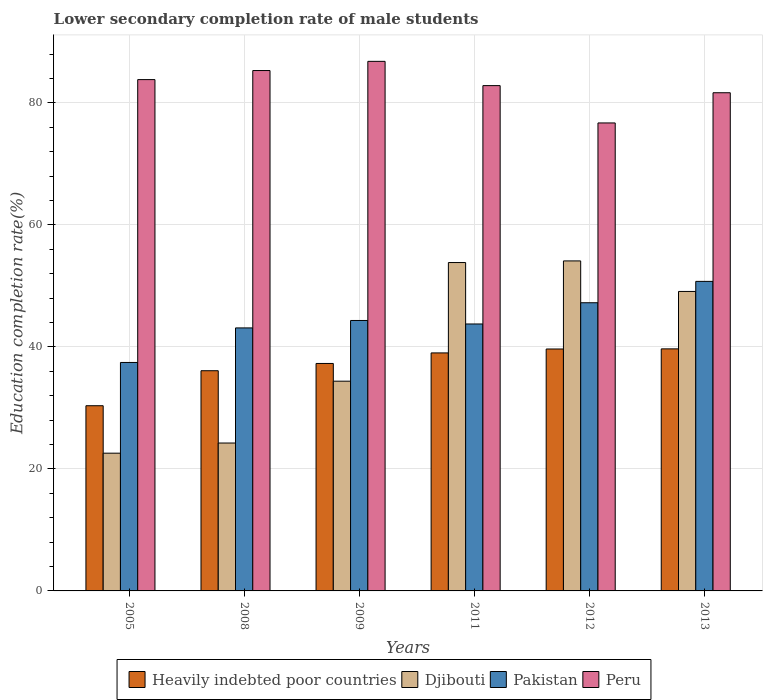How many different coloured bars are there?
Provide a succinct answer. 4. Are the number of bars per tick equal to the number of legend labels?
Give a very brief answer. Yes. How many bars are there on the 1st tick from the left?
Offer a very short reply. 4. How many bars are there on the 1st tick from the right?
Make the answer very short. 4. What is the label of the 1st group of bars from the left?
Your answer should be compact. 2005. What is the lower secondary completion rate of male students in Heavily indebted poor countries in 2008?
Make the answer very short. 36.09. Across all years, what is the maximum lower secondary completion rate of male students in Peru?
Your response must be concise. 86.8. Across all years, what is the minimum lower secondary completion rate of male students in Peru?
Your response must be concise. 76.71. In which year was the lower secondary completion rate of male students in Heavily indebted poor countries minimum?
Provide a succinct answer. 2005. What is the total lower secondary completion rate of male students in Heavily indebted poor countries in the graph?
Your response must be concise. 222.08. What is the difference between the lower secondary completion rate of male students in Peru in 2011 and that in 2012?
Offer a terse response. 6.12. What is the difference between the lower secondary completion rate of male students in Heavily indebted poor countries in 2008 and the lower secondary completion rate of male students in Pakistan in 2011?
Your answer should be compact. -7.66. What is the average lower secondary completion rate of male students in Heavily indebted poor countries per year?
Ensure brevity in your answer.  37.01. In the year 2008, what is the difference between the lower secondary completion rate of male students in Heavily indebted poor countries and lower secondary completion rate of male students in Peru?
Give a very brief answer. -49.2. What is the ratio of the lower secondary completion rate of male students in Heavily indebted poor countries in 2005 to that in 2011?
Make the answer very short. 0.78. Is the difference between the lower secondary completion rate of male students in Heavily indebted poor countries in 2005 and 2012 greater than the difference between the lower secondary completion rate of male students in Peru in 2005 and 2012?
Your answer should be compact. No. What is the difference between the highest and the second highest lower secondary completion rate of male students in Heavily indebted poor countries?
Ensure brevity in your answer.  0.02. What is the difference between the highest and the lowest lower secondary completion rate of male students in Peru?
Your response must be concise. 10.1. Is the sum of the lower secondary completion rate of male students in Heavily indebted poor countries in 2008 and 2009 greater than the maximum lower secondary completion rate of male students in Djibouti across all years?
Keep it short and to the point. Yes. What does the 2nd bar from the left in 2009 represents?
Keep it short and to the point. Djibouti. What does the 2nd bar from the right in 2013 represents?
Your answer should be very brief. Pakistan. Are all the bars in the graph horizontal?
Give a very brief answer. No. How many years are there in the graph?
Your answer should be compact. 6. What is the difference between two consecutive major ticks on the Y-axis?
Your answer should be very brief. 20. Does the graph contain grids?
Offer a very short reply. Yes. How many legend labels are there?
Provide a succinct answer. 4. What is the title of the graph?
Make the answer very short. Lower secondary completion rate of male students. What is the label or title of the X-axis?
Keep it short and to the point. Years. What is the label or title of the Y-axis?
Offer a terse response. Education completion rate(%). What is the Education completion rate(%) in Heavily indebted poor countries in 2005?
Give a very brief answer. 30.36. What is the Education completion rate(%) of Djibouti in 2005?
Ensure brevity in your answer.  22.58. What is the Education completion rate(%) in Pakistan in 2005?
Give a very brief answer. 37.45. What is the Education completion rate(%) in Peru in 2005?
Offer a terse response. 83.81. What is the Education completion rate(%) of Heavily indebted poor countries in 2008?
Keep it short and to the point. 36.09. What is the Education completion rate(%) of Djibouti in 2008?
Keep it short and to the point. 24.24. What is the Education completion rate(%) in Pakistan in 2008?
Give a very brief answer. 43.11. What is the Education completion rate(%) of Peru in 2008?
Make the answer very short. 85.3. What is the Education completion rate(%) in Heavily indebted poor countries in 2009?
Ensure brevity in your answer.  37.29. What is the Education completion rate(%) of Djibouti in 2009?
Offer a very short reply. 34.38. What is the Education completion rate(%) of Pakistan in 2009?
Keep it short and to the point. 44.33. What is the Education completion rate(%) of Peru in 2009?
Offer a very short reply. 86.8. What is the Education completion rate(%) of Heavily indebted poor countries in 2011?
Provide a succinct answer. 39.01. What is the Education completion rate(%) of Djibouti in 2011?
Offer a very short reply. 53.83. What is the Education completion rate(%) of Pakistan in 2011?
Offer a terse response. 43.76. What is the Education completion rate(%) of Peru in 2011?
Your answer should be compact. 82.83. What is the Education completion rate(%) in Heavily indebted poor countries in 2012?
Your answer should be compact. 39.65. What is the Education completion rate(%) of Djibouti in 2012?
Offer a very short reply. 54.09. What is the Education completion rate(%) of Pakistan in 2012?
Ensure brevity in your answer.  47.24. What is the Education completion rate(%) of Peru in 2012?
Give a very brief answer. 76.71. What is the Education completion rate(%) of Heavily indebted poor countries in 2013?
Give a very brief answer. 39.68. What is the Education completion rate(%) in Djibouti in 2013?
Offer a terse response. 49.09. What is the Education completion rate(%) in Pakistan in 2013?
Give a very brief answer. 50.74. What is the Education completion rate(%) in Peru in 2013?
Your response must be concise. 81.66. Across all years, what is the maximum Education completion rate(%) of Heavily indebted poor countries?
Provide a succinct answer. 39.68. Across all years, what is the maximum Education completion rate(%) in Djibouti?
Offer a very short reply. 54.09. Across all years, what is the maximum Education completion rate(%) in Pakistan?
Ensure brevity in your answer.  50.74. Across all years, what is the maximum Education completion rate(%) of Peru?
Make the answer very short. 86.8. Across all years, what is the minimum Education completion rate(%) of Heavily indebted poor countries?
Make the answer very short. 30.36. Across all years, what is the minimum Education completion rate(%) in Djibouti?
Keep it short and to the point. 22.58. Across all years, what is the minimum Education completion rate(%) of Pakistan?
Offer a terse response. 37.45. Across all years, what is the minimum Education completion rate(%) of Peru?
Offer a very short reply. 76.71. What is the total Education completion rate(%) in Heavily indebted poor countries in the graph?
Provide a succinct answer. 222.08. What is the total Education completion rate(%) of Djibouti in the graph?
Your response must be concise. 238.21. What is the total Education completion rate(%) of Pakistan in the graph?
Keep it short and to the point. 266.62. What is the total Education completion rate(%) of Peru in the graph?
Ensure brevity in your answer.  497.11. What is the difference between the Education completion rate(%) in Heavily indebted poor countries in 2005 and that in 2008?
Offer a very short reply. -5.74. What is the difference between the Education completion rate(%) of Djibouti in 2005 and that in 2008?
Your answer should be compact. -1.67. What is the difference between the Education completion rate(%) in Pakistan in 2005 and that in 2008?
Offer a very short reply. -5.66. What is the difference between the Education completion rate(%) in Peru in 2005 and that in 2008?
Your answer should be very brief. -1.49. What is the difference between the Education completion rate(%) in Heavily indebted poor countries in 2005 and that in 2009?
Provide a short and direct response. -6.93. What is the difference between the Education completion rate(%) of Djibouti in 2005 and that in 2009?
Provide a short and direct response. -11.8. What is the difference between the Education completion rate(%) of Pakistan in 2005 and that in 2009?
Keep it short and to the point. -6.88. What is the difference between the Education completion rate(%) in Peru in 2005 and that in 2009?
Make the answer very short. -2.99. What is the difference between the Education completion rate(%) in Heavily indebted poor countries in 2005 and that in 2011?
Your answer should be very brief. -8.66. What is the difference between the Education completion rate(%) in Djibouti in 2005 and that in 2011?
Offer a very short reply. -31.25. What is the difference between the Education completion rate(%) in Pakistan in 2005 and that in 2011?
Your response must be concise. -6.31. What is the difference between the Education completion rate(%) in Peru in 2005 and that in 2011?
Your answer should be very brief. 0.98. What is the difference between the Education completion rate(%) in Heavily indebted poor countries in 2005 and that in 2012?
Keep it short and to the point. -9.3. What is the difference between the Education completion rate(%) in Djibouti in 2005 and that in 2012?
Ensure brevity in your answer.  -31.52. What is the difference between the Education completion rate(%) of Pakistan in 2005 and that in 2012?
Your response must be concise. -9.79. What is the difference between the Education completion rate(%) in Peru in 2005 and that in 2012?
Your answer should be very brief. 7.1. What is the difference between the Education completion rate(%) of Heavily indebted poor countries in 2005 and that in 2013?
Your answer should be compact. -9.32. What is the difference between the Education completion rate(%) in Djibouti in 2005 and that in 2013?
Your answer should be compact. -26.51. What is the difference between the Education completion rate(%) in Pakistan in 2005 and that in 2013?
Give a very brief answer. -13.29. What is the difference between the Education completion rate(%) in Peru in 2005 and that in 2013?
Offer a very short reply. 2.15. What is the difference between the Education completion rate(%) of Heavily indebted poor countries in 2008 and that in 2009?
Offer a very short reply. -1.19. What is the difference between the Education completion rate(%) in Djibouti in 2008 and that in 2009?
Keep it short and to the point. -10.14. What is the difference between the Education completion rate(%) of Pakistan in 2008 and that in 2009?
Your response must be concise. -1.22. What is the difference between the Education completion rate(%) of Peru in 2008 and that in 2009?
Ensure brevity in your answer.  -1.51. What is the difference between the Education completion rate(%) of Heavily indebted poor countries in 2008 and that in 2011?
Your answer should be compact. -2.92. What is the difference between the Education completion rate(%) of Djibouti in 2008 and that in 2011?
Offer a very short reply. -29.58. What is the difference between the Education completion rate(%) of Pakistan in 2008 and that in 2011?
Provide a succinct answer. -0.64. What is the difference between the Education completion rate(%) in Peru in 2008 and that in 2011?
Ensure brevity in your answer.  2.47. What is the difference between the Education completion rate(%) in Heavily indebted poor countries in 2008 and that in 2012?
Offer a very short reply. -3.56. What is the difference between the Education completion rate(%) of Djibouti in 2008 and that in 2012?
Provide a succinct answer. -29.85. What is the difference between the Education completion rate(%) in Pakistan in 2008 and that in 2012?
Keep it short and to the point. -4.13. What is the difference between the Education completion rate(%) in Peru in 2008 and that in 2012?
Provide a short and direct response. 8.59. What is the difference between the Education completion rate(%) of Heavily indebted poor countries in 2008 and that in 2013?
Make the answer very short. -3.58. What is the difference between the Education completion rate(%) in Djibouti in 2008 and that in 2013?
Your answer should be compact. -24.84. What is the difference between the Education completion rate(%) in Pakistan in 2008 and that in 2013?
Give a very brief answer. -7.63. What is the difference between the Education completion rate(%) of Peru in 2008 and that in 2013?
Your answer should be very brief. 3.64. What is the difference between the Education completion rate(%) of Heavily indebted poor countries in 2009 and that in 2011?
Your answer should be very brief. -1.73. What is the difference between the Education completion rate(%) of Djibouti in 2009 and that in 2011?
Offer a very short reply. -19.45. What is the difference between the Education completion rate(%) in Pakistan in 2009 and that in 2011?
Your response must be concise. 0.57. What is the difference between the Education completion rate(%) in Peru in 2009 and that in 2011?
Make the answer very short. 3.98. What is the difference between the Education completion rate(%) in Heavily indebted poor countries in 2009 and that in 2012?
Provide a succinct answer. -2.37. What is the difference between the Education completion rate(%) of Djibouti in 2009 and that in 2012?
Keep it short and to the point. -19.71. What is the difference between the Education completion rate(%) in Pakistan in 2009 and that in 2012?
Keep it short and to the point. -2.91. What is the difference between the Education completion rate(%) in Peru in 2009 and that in 2012?
Ensure brevity in your answer.  10.1. What is the difference between the Education completion rate(%) of Heavily indebted poor countries in 2009 and that in 2013?
Your response must be concise. -2.39. What is the difference between the Education completion rate(%) in Djibouti in 2009 and that in 2013?
Your answer should be compact. -14.71. What is the difference between the Education completion rate(%) in Pakistan in 2009 and that in 2013?
Your answer should be very brief. -6.41. What is the difference between the Education completion rate(%) in Peru in 2009 and that in 2013?
Offer a terse response. 5.14. What is the difference between the Education completion rate(%) of Heavily indebted poor countries in 2011 and that in 2012?
Ensure brevity in your answer.  -0.64. What is the difference between the Education completion rate(%) of Djibouti in 2011 and that in 2012?
Ensure brevity in your answer.  -0.27. What is the difference between the Education completion rate(%) of Pakistan in 2011 and that in 2012?
Offer a terse response. -3.48. What is the difference between the Education completion rate(%) of Peru in 2011 and that in 2012?
Make the answer very short. 6.12. What is the difference between the Education completion rate(%) in Heavily indebted poor countries in 2011 and that in 2013?
Offer a very short reply. -0.66. What is the difference between the Education completion rate(%) in Djibouti in 2011 and that in 2013?
Offer a very short reply. 4.74. What is the difference between the Education completion rate(%) of Pakistan in 2011 and that in 2013?
Your answer should be very brief. -6.98. What is the difference between the Education completion rate(%) of Peru in 2011 and that in 2013?
Give a very brief answer. 1.17. What is the difference between the Education completion rate(%) of Heavily indebted poor countries in 2012 and that in 2013?
Ensure brevity in your answer.  -0.02. What is the difference between the Education completion rate(%) in Djibouti in 2012 and that in 2013?
Your answer should be very brief. 5. What is the difference between the Education completion rate(%) of Pakistan in 2012 and that in 2013?
Provide a succinct answer. -3.5. What is the difference between the Education completion rate(%) in Peru in 2012 and that in 2013?
Make the answer very short. -4.95. What is the difference between the Education completion rate(%) of Heavily indebted poor countries in 2005 and the Education completion rate(%) of Djibouti in 2008?
Offer a very short reply. 6.11. What is the difference between the Education completion rate(%) of Heavily indebted poor countries in 2005 and the Education completion rate(%) of Pakistan in 2008?
Offer a very short reply. -12.76. What is the difference between the Education completion rate(%) of Heavily indebted poor countries in 2005 and the Education completion rate(%) of Peru in 2008?
Provide a succinct answer. -54.94. What is the difference between the Education completion rate(%) of Djibouti in 2005 and the Education completion rate(%) of Pakistan in 2008?
Your answer should be very brief. -20.53. What is the difference between the Education completion rate(%) of Djibouti in 2005 and the Education completion rate(%) of Peru in 2008?
Provide a succinct answer. -62.72. What is the difference between the Education completion rate(%) in Pakistan in 2005 and the Education completion rate(%) in Peru in 2008?
Make the answer very short. -47.85. What is the difference between the Education completion rate(%) in Heavily indebted poor countries in 2005 and the Education completion rate(%) in Djibouti in 2009?
Give a very brief answer. -4.02. What is the difference between the Education completion rate(%) of Heavily indebted poor countries in 2005 and the Education completion rate(%) of Pakistan in 2009?
Give a very brief answer. -13.97. What is the difference between the Education completion rate(%) in Heavily indebted poor countries in 2005 and the Education completion rate(%) in Peru in 2009?
Provide a short and direct response. -56.45. What is the difference between the Education completion rate(%) in Djibouti in 2005 and the Education completion rate(%) in Pakistan in 2009?
Offer a terse response. -21.75. What is the difference between the Education completion rate(%) of Djibouti in 2005 and the Education completion rate(%) of Peru in 2009?
Offer a terse response. -64.23. What is the difference between the Education completion rate(%) in Pakistan in 2005 and the Education completion rate(%) in Peru in 2009?
Ensure brevity in your answer.  -49.36. What is the difference between the Education completion rate(%) in Heavily indebted poor countries in 2005 and the Education completion rate(%) in Djibouti in 2011?
Your response must be concise. -23.47. What is the difference between the Education completion rate(%) in Heavily indebted poor countries in 2005 and the Education completion rate(%) in Pakistan in 2011?
Provide a short and direct response. -13.4. What is the difference between the Education completion rate(%) of Heavily indebted poor countries in 2005 and the Education completion rate(%) of Peru in 2011?
Keep it short and to the point. -52.47. What is the difference between the Education completion rate(%) in Djibouti in 2005 and the Education completion rate(%) in Pakistan in 2011?
Give a very brief answer. -21.18. What is the difference between the Education completion rate(%) of Djibouti in 2005 and the Education completion rate(%) of Peru in 2011?
Ensure brevity in your answer.  -60.25. What is the difference between the Education completion rate(%) in Pakistan in 2005 and the Education completion rate(%) in Peru in 2011?
Your answer should be compact. -45.38. What is the difference between the Education completion rate(%) of Heavily indebted poor countries in 2005 and the Education completion rate(%) of Djibouti in 2012?
Give a very brief answer. -23.74. What is the difference between the Education completion rate(%) in Heavily indebted poor countries in 2005 and the Education completion rate(%) in Pakistan in 2012?
Ensure brevity in your answer.  -16.88. What is the difference between the Education completion rate(%) in Heavily indebted poor countries in 2005 and the Education completion rate(%) in Peru in 2012?
Make the answer very short. -46.35. What is the difference between the Education completion rate(%) of Djibouti in 2005 and the Education completion rate(%) of Pakistan in 2012?
Your answer should be very brief. -24.66. What is the difference between the Education completion rate(%) in Djibouti in 2005 and the Education completion rate(%) in Peru in 2012?
Ensure brevity in your answer.  -54.13. What is the difference between the Education completion rate(%) of Pakistan in 2005 and the Education completion rate(%) of Peru in 2012?
Keep it short and to the point. -39.26. What is the difference between the Education completion rate(%) in Heavily indebted poor countries in 2005 and the Education completion rate(%) in Djibouti in 2013?
Ensure brevity in your answer.  -18.73. What is the difference between the Education completion rate(%) of Heavily indebted poor countries in 2005 and the Education completion rate(%) of Pakistan in 2013?
Provide a succinct answer. -20.38. What is the difference between the Education completion rate(%) of Heavily indebted poor countries in 2005 and the Education completion rate(%) of Peru in 2013?
Provide a short and direct response. -51.3. What is the difference between the Education completion rate(%) in Djibouti in 2005 and the Education completion rate(%) in Pakistan in 2013?
Provide a succinct answer. -28.16. What is the difference between the Education completion rate(%) in Djibouti in 2005 and the Education completion rate(%) in Peru in 2013?
Provide a short and direct response. -59.08. What is the difference between the Education completion rate(%) in Pakistan in 2005 and the Education completion rate(%) in Peru in 2013?
Your answer should be compact. -44.21. What is the difference between the Education completion rate(%) of Heavily indebted poor countries in 2008 and the Education completion rate(%) of Djibouti in 2009?
Your answer should be compact. 1.72. What is the difference between the Education completion rate(%) in Heavily indebted poor countries in 2008 and the Education completion rate(%) in Pakistan in 2009?
Offer a terse response. -8.24. What is the difference between the Education completion rate(%) of Heavily indebted poor countries in 2008 and the Education completion rate(%) of Peru in 2009?
Ensure brevity in your answer.  -50.71. What is the difference between the Education completion rate(%) in Djibouti in 2008 and the Education completion rate(%) in Pakistan in 2009?
Provide a short and direct response. -20.09. What is the difference between the Education completion rate(%) in Djibouti in 2008 and the Education completion rate(%) in Peru in 2009?
Provide a succinct answer. -62.56. What is the difference between the Education completion rate(%) of Pakistan in 2008 and the Education completion rate(%) of Peru in 2009?
Your answer should be compact. -43.69. What is the difference between the Education completion rate(%) of Heavily indebted poor countries in 2008 and the Education completion rate(%) of Djibouti in 2011?
Offer a very short reply. -17.73. What is the difference between the Education completion rate(%) of Heavily indebted poor countries in 2008 and the Education completion rate(%) of Pakistan in 2011?
Offer a terse response. -7.66. What is the difference between the Education completion rate(%) of Heavily indebted poor countries in 2008 and the Education completion rate(%) of Peru in 2011?
Give a very brief answer. -46.73. What is the difference between the Education completion rate(%) in Djibouti in 2008 and the Education completion rate(%) in Pakistan in 2011?
Offer a very short reply. -19.51. What is the difference between the Education completion rate(%) in Djibouti in 2008 and the Education completion rate(%) in Peru in 2011?
Your answer should be compact. -58.58. What is the difference between the Education completion rate(%) in Pakistan in 2008 and the Education completion rate(%) in Peru in 2011?
Give a very brief answer. -39.72. What is the difference between the Education completion rate(%) of Heavily indebted poor countries in 2008 and the Education completion rate(%) of Djibouti in 2012?
Provide a succinct answer. -18. What is the difference between the Education completion rate(%) of Heavily indebted poor countries in 2008 and the Education completion rate(%) of Pakistan in 2012?
Offer a very short reply. -11.14. What is the difference between the Education completion rate(%) of Heavily indebted poor countries in 2008 and the Education completion rate(%) of Peru in 2012?
Give a very brief answer. -40.61. What is the difference between the Education completion rate(%) in Djibouti in 2008 and the Education completion rate(%) in Pakistan in 2012?
Your answer should be very brief. -22.99. What is the difference between the Education completion rate(%) of Djibouti in 2008 and the Education completion rate(%) of Peru in 2012?
Keep it short and to the point. -52.46. What is the difference between the Education completion rate(%) in Pakistan in 2008 and the Education completion rate(%) in Peru in 2012?
Your response must be concise. -33.6. What is the difference between the Education completion rate(%) of Heavily indebted poor countries in 2008 and the Education completion rate(%) of Djibouti in 2013?
Your answer should be very brief. -12.99. What is the difference between the Education completion rate(%) of Heavily indebted poor countries in 2008 and the Education completion rate(%) of Pakistan in 2013?
Make the answer very short. -14.64. What is the difference between the Education completion rate(%) in Heavily indebted poor countries in 2008 and the Education completion rate(%) in Peru in 2013?
Offer a very short reply. -45.57. What is the difference between the Education completion rate(%) in Djibouti in 2008 and the Education completion rate(%) in Pakistan in 2013?
Keep it short and to the point. -26.49. What is the difference between the Education completion rate(%) of Djibouti in 2008 and the Education completion rate(%) of Peru in 2013?
Ensure brevity in your answer.  -57.42. What is the difference between the Education completion rate(%) of Pakistan in 2008 and the Education completion rate(%) of Peru in 2013?
Your answer should be compact. -38.55. What is the difference between the Education completion rate(%) in Heavily indebted poor countries in 2009 and the Education completion rate(%) in Djibouti in 2011?
Provide a succinct answer. -16.54. What is the difference between the Education completion rate(%) in Heavily indebted poor countries in 2009 and the Education completion rate(%) in Pakistan in 2011?
Offer a terse response. -6.47. What is the difference between the Education completion rate(%) in Heavily indebted poor countries in 2009 and the Education completion rate(%) in Peru in 2011?
Your answer should be compact. -45.54. What is the difference between the Education completion rate(%) of Djibouti in 2009 and the Education completion rate(%) of Pakistan in 2011?
Offer a very short reply. -9.38. What is the difference between the Education completion rate(%) in Djibouti in 2009 and the Education completion rate(%) in Peru in 2011?
Provide a succinct answer. -48.45. What is the difference between the Education completion rate(%) in Pakistan in 2009 and the Education completion rate(%) in Peru in 2011?
Make the answer very short. -38.5. What is the difference between the Education completion rate(%) of Heavily indebted poor countries in 2009 and the Education completion rate(%) of Djibouti in 2012?
Your answer should be compact. -16.81. What is the difference between the Education completion rate(%) of Heavily indebted poor countries in 2009 and the Education completion rate(%) of Pakistan in 2012?
Give a very brief answer. -9.95. What is the difference between the Education completion rate(%) in Heavily indebted poor countries in 2009 and the Education completion rate(%) in Peru in 2012?
Ensure brevity in your answer.  -39.42. What is the difference between the Education completion rate(%) of Djibouti in 2009 and the Education completion rate(%) of Pakistan in 2012?
Keep it short and to the point. -12.86. What is the difference between the Education completion rate(%) of Djibouti in 2009 and the Education completion rate(%) of Peru in 2012?
Offer a terse response. -42.33. What is the difference between the Education completion rate(%) in Pakistan in 2009 and the Education completion rate(%) in Peru in 2012?
Offer a very short reply. -32.38. What is the difference between the Education completion rate(%) in Heavily indebted poor countries in 2009 and the Education completion rate(%) in Djibouti in 2013?
Give a very brief answer. -11.8. What is the difference between the Education completion rate(%) in Heavily indebted poor countries in 2009 and the Education completion rate(%) in Pakistan in 2013?
Offer a terse response. -13.45. What is the difference between the Education completion rate(%) in Heavily indebted poor countries in 2009 and the Education completion rate(%) in Peru in 2013?
Your response must be concise. -44.38. What is the difference between the Education completion rate(%) in Djibouti in 2009 and the Education completion rate(%) in Pakistan in 2013?
Your response must be concise. -16.36. What is the difference between the Education completion rate(%) of Djibouti in 2009 and the Education completion rate(%) of Peru in 2013?
Your answer should be very brief. -47.28. What is the difference between the Education completion rate(%) in Pakistan in 2009 and the Education completion rate(%) in Peru in 2013?
Offer a terse response. -37.33. What is the difference between the Education completion rate(%) in Heavily indebted poor countries in 2011 and the Education completion rate(%) in Djibouti in 2012?
Your answer should be very brief. -15.08. What is the difference between the Education completion rate(%) in Heavily indebted poor countries in 2011 and the Education completion rate(%) in Pakistan in 2012?
Make the answer very short. -8.22. What is the difference between the Education completion rate(%) of Heavily indebted poor countries in 2011 and the Education completion rate(%) of Peru in 2012?
Give a very brief answer. -37.7. What is the difference between the Education completion rate(%) of Djibouti in 2011 and the Education completion rate(%) of Pakistan in 2012?
Offer a very short reply. 6.59. What is the difference between the Education completion rate(%) in Djibouti in 2011 and the Education completion rate(%) in Peru in 2012?
Keep it short and to the point. -22.88. What is the difference between the Education completion rate(%) in Pakistan in 2011 and the Education completion rate(%) in Peru in 2012?
Offer a very short reply. -32.95. What is the difference between the Education completion rate(%) in Heavily indebted poor countries in 2011 and the Education completion rate(%) in Djibouti in 2013?
Ensure brevity in your answer.  -10.08. What is the difference between the Education completion rate(%) of Heavily indebted poor countries in 2011 and the Education completion rate(%) of Pakistan in 2013?
Your answer should be compact. -11.73. What is the difference between the Education completion rate(%) in Heavily indebted poor countries in 2011 and the Education completion rate(%) in Peru in 2013?
Ensure brevity in your answer.  -42.65. What is the difference between the Education completion rate(%) in Djibouti in 2011 and the Education completion rate(%) in Pakistan in 2013?
Provide a succinct answer. 3.09. What is the difference between the Education completion rate(%) of Djibouti in 2011 and the Education completion rate(%) of Peru in 2013?
Give a very brief answer. -27.83. What is the difference between the Education completion rate(%) of Pakistan in 2011 and the Education completion rate(%) of Peru in 2013?
Keep it short and to the point. -37.9. What is the difference between the Education completion rate(%) in Heavily indebted poor countries in 2012 and the Education completion rate(%) in Djibouti in 2013?
Make the answer very short. -9.43. What is the difference between the Education completion rate(%) in Heavily indebted poor countries in 2012 and the Education completion rate(%) in Pakistan in 2013?
Make the answer very short. -11.08. What is the difference between the Education completion rate(%) of Heavily indebted poor countries in 2012 and the Education completion rate(%) of Peru in 2013?
Give a very brief answer. -42.01. What is the difference between the Education completion rate(%) of Djibouti in 2012 and the Education completion rate(%) of Pakistan in 2013?
Your response must be concise. 3.35. What is the difference between the Education completion rate(%) in Djibouti in 2012 and the Education completion rate(%) in Peru in 2013?
Offer a very short reply. -27.57. What is the difference between the Education completion rate(%) in Pakistan in 2012 and the Education completion rate(%) in Peru in 2013?
Your answer should be compact. -34.42. What is the average Education completion rate(%) of Heavily indebted poor countries per year?
Keep it short and to the point. 37.01. What is the average Education completion rate(%) in Djibouti per year?
Provide a succinct answer. 39.7. What is the average Education completion rate(%) in Pakistan per year?
Your response must be concise. 44.44. What is the average Education completion rate(%) in Peru per year?
Your response must be concise. 82.85. In the year 2005, what is the difference between the Education completion rate(%) of Heavily indebted poor countries and Education completion rate(%) of Djibouti?
Provide a short and direct response. 7.78. In the year 2005, what is the difference between the Education completion rate(%) of Heavily indebted poor countries and Education completion rate(%) of Pakistan?
Give a very brief answer. -7.09. In the year 2005, what is the difference between the Education completion rate(%) in Heavily indebted poor countries and Education completion rate(%) in Peru?
Give a very brief answer. -53.46. In the year 2005, what is the difference between the Education completion rate(%) in Djibouti and Education completion rate(%) in Pakistan?
Offer a very short reply. -14.87. In the year 2005, what is the difference between the Education completion rate(%) in Djibouti and Education completion rate(%) in Peru?
Your response must be concise. -61.23. In the year 2005, what is the difference between the Education completion rate(%) in Pakistan and Education completion rate(%) in Peru?
Your answer should be compact. -46.36. In the year 2008, what is the difference between the Education completion rate(%) in Heavily indebted poor countries and Education completion rate(%) in Djibouti?
Offer a very short reply. 11.85. In the year 2008, what is the difference between the Education completion rate(%) of Heavily indebted poor countries and Education completion rate(%) of Pakistan?
Offer a very short reply. -7.02. In the year 2008, what is the difference between the Education completion rate(%) of Heavily indebted poor countries and Education completion rate(%) of Peru?
Provide a succinct answer. -49.2. In the year 2008, what is the difference between the Education completion rate(%) of Djibouti and Education completion rate(%) of Pakistan?
Your answer should be very brief. -18.87. In the year 2008, what is the difference between the Education completion rate(%) in Djibouti and Education completion rate(%) in Peru?
Provide a short and direct response. -61.05. In the year 2008, what is the difference between the Education completion rate(%) of Pakistan and Education completion rate(%) of Peru?
Give a very brief answer. -42.19. In the year 2009, what is the difference between the Education completion rate(%) in Heavily indebted poor countries and Education completion rate(%) in Djibouti?
Ensure brevity in your answer.  2.91. In the year 2009, what is the difference between the Education completion rate(%) in Heavily indebted poor countries and Education completion rate(%) in Pakistan?
Your answer should be very brief. -7.04. In the year 2009, what is the difference between the Education completion rate(%) of Heavily indebted poor countries and Education completion rate(%) of Peru?
Make the answer very short. -49.52. In the year 2009, what is the difference between the Education completion rate(%) in Djibouti and Education completion rate(%) in Pakistan?
Give a very brief answer. -9.95. In the year 2009, what is the difference between the Education completion rate(%) in Djibouti and Education completion rate(%) in Peru?
Make the answer very short. -52.43. In the year 2009, what is the difference between the Education completion rate(%) of Pakistan and Education completion rate(%) of Peru?
Your response must be concise. -42.48. In the year 2011, what is the difference between the Education completion rate(%) in Heavily indebted poor countries and Education completion rate(%) in Djibouti?
Make the answer very short. -14.81. In the year 2011, what is the difference between the Education completion rate(%) of Heavily indebted poor countries and Education completion rate(%) of Pakistan?
Offer a very short reply. -4.74. In the year 2011, what is the difference between the Education completion rate(%) in Heavily indebted poor countries and Education completion rate(%) in Peru?
Provide a short and direct response. -43.82. In the year 2011, what is the difference between the Education completion rate(%) of Djibouti and Education completion rate(%) of Pakistan?
Ensure brevity in your answer.  10.07. In the year 2011, what is the difference between the Education completion rate(%) of Djibouti and Education completion rate(%) of Peru?
Your response must be concise. -29. In the year 2011, what is the difference between the Education completion rate(%) of Pakistan and Education completion rate(%) of Peru?
Make the answer very short. -39.07. In the year 2012, what is the difference between the Education completion rate(%) of Heavily indebted poor countries and Education completion rate(%) of Djibouti?
Ensure brevity in your answer.  -14.44. In the year 2012, what is the difference between the Education completion rate(%) of Heavily indebted poor countries and Education completion rate(%) of Pakistan?
Your response must be concise. -7.58. In the year 2012, what is the difference between the Education completion rate(%) of Heavily indebted poor countries and Education completion rate(%) of Peru?
Keep it short and to the point. -37.05. In the year 2012, what is the difference between the Education completion rate(%) of Djibouti and Education completion rate(%) of Pakistan?
Give a very brief answer. 6.86. In the year 2012, what is the difference between the Education completion rate(%) in Djibouti and Education completion rate(%) in Peru?
Provide a succinct answer. -22.62. In the year 2012, what is the difference between the Education completion rate(%) in Pakistan and Education completion rate(%) in Peru?
Your answer should be very brief. -29.47. In the year 2013, what is the difference between the Education completion rate(%) in Heavily indebted poor countries and Education completion rate(%) in Djibouti?
Your answer should be very brief. -9.41. In the year 2013, what is the difference between the Education completion rate(%) of Heavily indebted poor countries and Education completion rate(%) of Pakistan?
Provide a succinct answer. -11.06. In the year 2013, what is the difference between the Education completion rate(%) in Heavily indebted poor countries and Education completion rate(%) in Peru?
Offer a terse response. -41.98. In the year 2013, what is the difference between the Education completion rate(%) of Djibouti and Education completion rate(%) of Pakistan?
Your response must be concise. -1.65. In the year 2013, what is the difference between the Education completion rate(%) of Djibouti and Education completion rate(%) of Peru?
Ensure brevity in your answer.  -32.57. In the year 2013, what is the difference between the Education completion rate(%) in Pakistan and Education completion rate(%) in Peru?
Your response must be concise. -30.92. What is the ratio of the Education completion rate(%) in Heavily indebted poor countries in 2005 to that in 2008?
Offer a terse response. 0.84. What is the ratio of the Education completion rate(%) of Djibouti in 2005 to that in 2008?
Provide a short and direct response. 0.93. What is the ratio of the Education completion rate(%) in Pakistan in 2005 to that in 2008?
Your answer should be compact. 0.87. What is the ratio of the Education completion rate(%) of Peru in 2005 to that in 2008?
Make the answer very short. 0.98. What is the ratio of the Education completion rate(%) in Heavily indebted poor countries in 2005 to that in 2009?
Provide a short and direct response. 0.81. What is the ratio of the Education completion rate(%) of Djibouti in 2005 to that in 2009?
Offer a very short reply. 0.66. What is the ratio of the Education completion rate(%) in Pakistan in 2005 to that in 2009?
Your answer should be very brief. 0.84. What is the ratio of the Education completion rate(%) of Peru in 2005 to that in 2009?
Make the answer very short. 0.97. What is the ratio of the Education completion rate(%) in Heavily indebted poor countries in 2005 to that in 2011?
Your response must be concise. 0.78. What is the ratio of the Education completion rate(%) in Djibouti in 2005 to that in 2011?
Keep it short and to the point. 0.42. What is the ratio of the Education completion rate(%) in Pakistan in 2005 to that in 2011?
Provide a short and direct response. 0.86. What is the ratio of the Education completion rate(%) of Peru in 2005 to that in 2011?
Give a very brief answer. 1.01. What is the ratio of the Education completion rate(%) in Heavily indebted poor countries in 2005 to that in 2012?
Offer a terse response. 0.77. What is the ratio of the Education completion rate(%) in Djibouti in 2005 to that in 2012?
Your answer should be compact. 0.42. What is the ratio of the Education completion rate(%) of Pakistan in 2005 to that in 2012?
Provide a succinct answer. 0.79. What is the ratio of the Education completion rate(%) in Peru in 2005 to that in 2012?
Provide a short and direct response. 1.09. What is the ratio of the Education completion rate(%) in Heavily indebted poor countries in 2005 to that in 2013?
Make the answer very short. 0.77. What is the ratio of the Education completion rate(%) in Djibouti in 2005 to that in 2013?
Keep it short and to the point. 0.46. What is the ratio of the Education completion rate(%) of Pakistan in 2005 to that in 2013?
Ensure brevity in your answer.  0.74. What is the ratio of the Education completion rate(%) in Peru in 2005 to that in 2013?
Keep it short and to the point. 1.03. What is the ratio of the Education completion rate(%) in Heavily indebted poor countries in 2008 to that in 2009?
Provide a short and direct response. 0.97. What is the ratio of the Education completion rate(%) of Djibouti in 2008 to that in 2009?
Provide a short and direct response. 0.71. What is the ratio of the Education completion rate(%) in Pakistan in 2008 to that in 2009?
Provide a succinct answer. 0.97. What is the ratio of the Education completion rate(%) in Peru in 2008 to that in 2009?
Your answer should be compact. 0.98. What is the ratio of the Education completion rate(%) of Heavily indebted poor countries in 2008 to that in 2011?
Give a very brief answer. 0.93. What is the ratio of the Education completion rate(%) in Djibouti in 2008 to that in 2011?
Your response must be concise. 0.45. What is the ratio of the Education completion rate(%) of Peru in 2008 to that in 2011?
Keep it short and to the point. 1.03. What is the ratio of the Education completion rate(%) in Heavily indebted poor countries in 2008 to that in 2012?
Provide a succinct answer. 0.91. What is the ratio of the Education completion rate(%) of Djibouti in 2008 to that in 2012?
Offer a very short reply. 0.45. What is the ratio of the Education completion rate(%) of Pakistan in 2008 to that in 2012?
Your answer should be compact. 0.91. What is the ratio of the Education completion rate(%) in Peru in 2008 to that in 2012?
Keep it short and to the point. 1.11. What is the ratio of the Education completion rate(%) of Heavily indebted poor countries in 2008 to that in 2013?
Keep it short and to the point. 0.91. What is the ratio of the Education completion rate(%) of Djibouti in 2008 to that in 2013?
Keep it short and to the point. 0.49. What is the ratio of the Education completion rate(%) of Pakistan in 2008 to that in 2013?
Offer a terse response. 0.85. What is the ratio of the Education completion rate(%) in Peru in 2008 to that in 2013?
Offer a terse response. 1.04. What is the ratio of the Education completion rate(%) of Heavily indebted poor countries in 2009 to that in 2011?
Ensure brevity in your answer.  0.96. What is the ratio of the Education completion rate(%) of Djibouti in 2009 to that in 2011?
Offer a very short reply. 0.64. What is the ratio of the Education completion rate(%) in Pakistan in 2009 to that in 2011?
Make the answer very short. 1.01. What is the ratio of the Education completion rate(%) of Peru in 2009 to that in 2011?
Your answer should be compact. 1.05. What is the ratio of the Education completion rate(%) in Heavily indebted poor countries in 2009 to that in 2012?
Your answer should be compact. 0.94. What is the ratio of the Education completion rate(%) in Djibouti in 2009 to that in 2012?
Offer a terse response. 0.64. What is the ratio of the Education completion rate(%) in Pakistan in 2009 to that in 2012?
Provide a succinct answer. 0.94. What is the ratio of the Education completion rate(%) of Peru in 2009 to that in 2012?
Your answer should be very brief. 1.13. What is the ratio of the Education completion rate(%) in Heavily indebted poor countries in 2009 to that in 2013?
Provide a succinct answer. 0.94. What is the ratio of the Education completion rate(%) of Djibouti in 2009 to that in 2013?
Provide a short and direct response. 0.7. What is the ratio of the Education completion rate(%) in Pakistan in 2009 to that in 2013?
Offer a terse response. 0.87. What is the ratio of the Education completion rate(%) in Peru in 2009 to that in 2013?
Your answer should be compact. 1.06. What is the ratio of the Education completion rate(%) of Heavily indebted poor countries in 2011 to that in 2012?
Offer a terse response. 0.98. What is the ratio of the Education completion rate(%) of Djibouti in 2011 to that in 2012?
Offer a terse response. 1. What is the ratio of the Education completion rate(%) in Pakistan in 2011 to that in 2012?
Keep it short and to the point. 0.93. What is the ratio of the Education completion rate(%) of Peru in 2011 to that in 2012?
Provide a succinct answer. 1.08. What is the ratio of the Education completion rate(%) of Heavily indebted poor countries in 2011 to that in 2013?
Your answer should be compact. 0.98. What is the ratio of the Education completion rate(%) of Djibouti in 2011 to that in 2013?
Keep it short and to the point. 1.1. What is the ratio of the Education completion rate(%) of Pakistan in 2011 to that in 2013?
Your answer should be compact. 0.86. What is the ratio of the Education completion rate(%) in Peru in 2011 to that in 2013?
Keep it short and to the point. 1.01. What is the ratio of the Education completion rate(%) in Heavily indebted poor countries in 2012 to that in 2013?
Ensure brevity in your answer.  1. What is the ratio of the Education completion rate(%) in Djibouti in 2012 to that in 2013?
Your response must be concise. 1.1. What is the ratio of the Education completion rate(%) in Pakistan in 2012 to that in 2013?
Provide a short and direct response. 0.93. What is the ratio of the Education completion rate(%) of Peru in 2012 to that in 2013?
Provide a short and direct response. 0.94. What is the difference between the highest and the second highest Education completion rate(%) of Heavily indebted poor countries?
Provide a succinct answer. 0.02. What is the difference between the highest and the second highest Education completion rate(%) in Djibouti?
Ensure brevity in your answer.  0.27. What is the difference between the highest and the second highest Education completion rate(%) of Pakistan?
Provide a short and direct response. 3.5. What is the difference between the highest and the second highest Education completion rate(%) of Peru?
Your response must be concise. 1.51. What is the difference between the highest and the lowest Education completion rate(%) in Heavily indebted poor countries?
Make the answer very short. 9.32. What is the difference between the highest and the lowest Education completion rate(%) of Djibouti?
Your answer should be very brief. 31.52. What is the difference between the highest and the lowest Education completion rate(%) of Pakistan?
Provide a succinct answer. 13.29. What is the difference between the highest and the lowest Education completion rate(%) in Peru?
Provide a succinct answer. 10.1. 